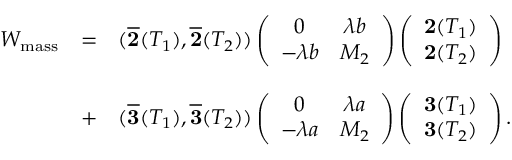Convert formula to latex. <formula><loc_0><loc_0><loc_500><loc_500>\begin{array} { c c l } { { W _ { m a s s } } } & { = } & { { ( \overline { 2 } ( T _ { 1 } ) , \overline { 2 } ( T _ { 2 } ) ) \left ( \begin{array} { c c } { 0 } & { \lambda b } \\ { - \lambda b } & { { M _ { 2 } } } \end{array} \right ) \left ( \begin{array} { c } { { { 2 } ( T _ { 1 } ) } } \\ { { { 2 } ( T _ { 2 } ) } } \end{array} \right ) } } & { + } & { { ( \overline { 3 } ( T _ { 1 } ) , \overline { 3 } ( T _ { 2 } ) ) \left ( \begin{array} { c c } { 0 } & { \lambda a } \\ { - \lambda a } & { { M _ { 2 } } } \end{array} \right ) \left ( \begin{array} { c } { { { 3 } ( T _ { 1 } ) } } \\ { { { 3 } ( T _ { 2 } ) } } \end{array} \right ) . } } \end{array}</formula> 